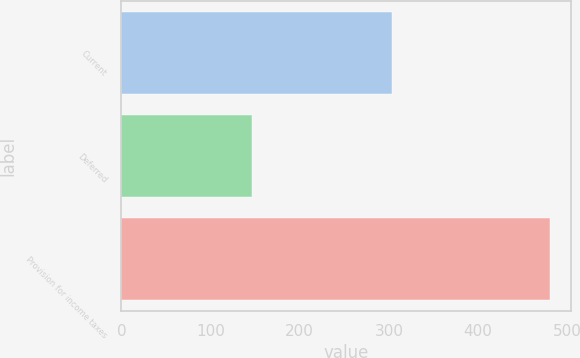<chart> <loc_0><loc_0><loc_500><loc_500><bar_chart><fcel>Current<fcel>Deferred<fcel>Provision for income taxes<nl><fcel>303<fcel>146<fcel>480<nl></chart> 